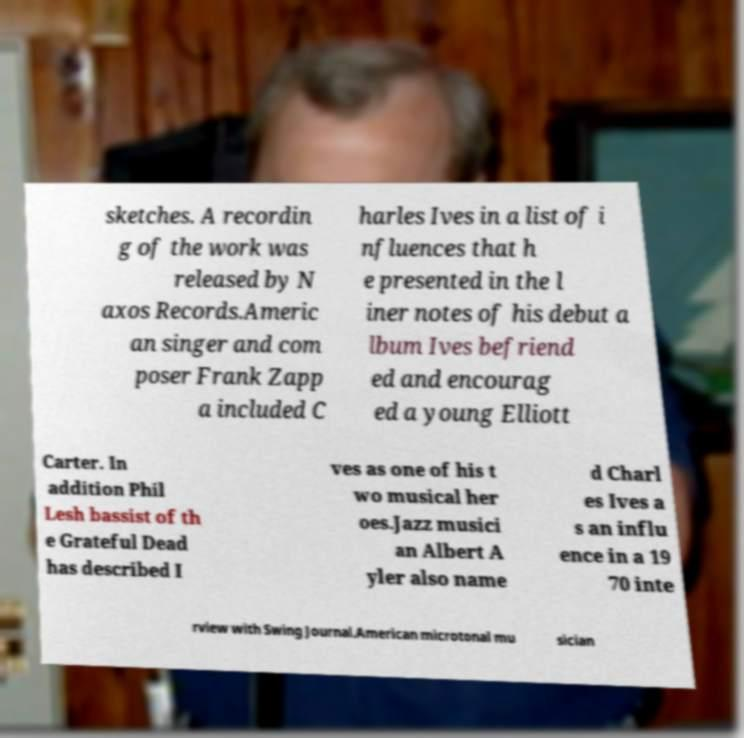What messages or text are displayed in this image? I need them in a readable, typed format. sketches. A recordin g of the work was released by N axos Records.Americ an singer and com poser Frank Zapp a included C harles Ives in a list of i nfluences that h e presented in the l iner notes of his debut a lbum Ives befriend ed and encourag ed a young Elliott Carter. In addition Phil Lesh bassist of th e Grateful Dead has described I ves as one of his t wo musical her oes.Jazz musici an Albert A yler also name d Charl es Ives a s an influ ence in a 19 70 inte rview with Swing Journal.American microtonal mu sician 